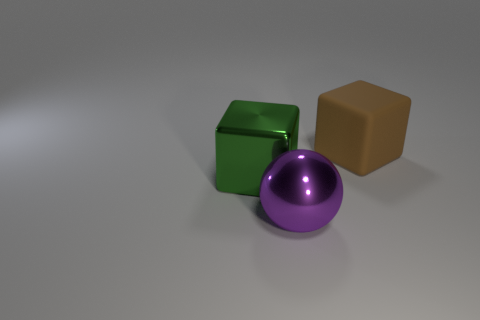The big block in front of the block that is on the right side of the large cube in front of the brown rubber cube is what color?
Your answer should be compact. Green. Is the material of the large object behind the big green metal thing the same as the large thing on the left side of the big purple sphere?
Offer a terse response. No. There is a large metal thing that is in front of the big green metallic thing; what is its shape?
Your answer should be very brief. Sphere. What number of things are either big purple shiny balls or shiny objects that are on the left side of the large purple object?
Provide a short and direct response. 2. Is the purple ball made of the same material as the big green block?
Your answer should be compact. Yes. Is the number of big shiny things behind the large green shiny object the same as the number of green metal blocks on the right side of the brown object?
Give a very brief answer. Yes. What number of purple objects are behind the big matte thing?
Ensure brevity in your answer.  0. How many things are either big red cylinders or purple metal balls?
Your response must be concise. 1. What number of purple metal things are the same size as the brown thing?
Your response must be concise. 1. There is a large thing that is in front of the cube that is to the left of the big matte thing; what is its shape?
Provide a succinct answer. Sphere. 